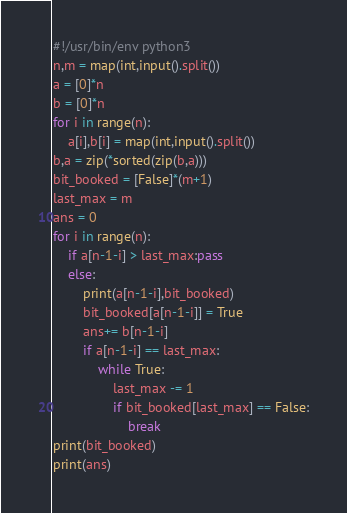Convert code to text. <code><loc_0><loc_0><loc_500><loc_500><_Python_>#!/usr/bin/env python3
n,m = map(int,input().split())
a = [0]*n
b = [0]*n
for i in range(n):
    a[i],b[i] = map(int,input().split())
b,a = zip(*sorted(zip(b,a)))
bit_booked = [False]*(m+1)
last_max = m
ans = 0
for i in range(n):
    if a[n-1-i] > last_max:pass
    else:
        print(a[n-1-i],bit_booked)
        bit_booked[a[n-1-i]] = True
        ans+= b[n-1-i]
        if a[n-1-i] == last_max:
            while True:
                last_max -= 1
                if bit_booked[last_max] == False:
                    break
print(bit_booked)
print(ans)</code> 